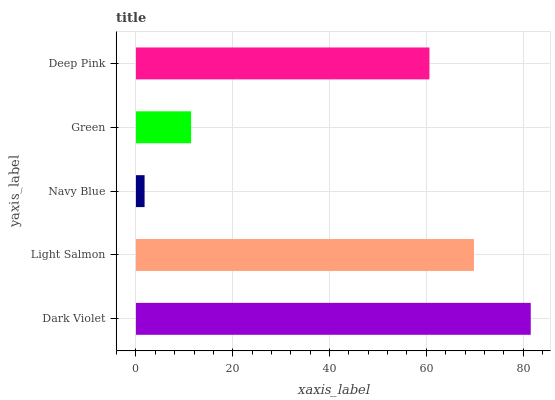Is Navy Blue the minimum?
Answer yes or no. Yes. Is Dark Violet the maximum?
Answer yes or no. Yes. Is Light Salmon the minimum?
Answer yes or no. No. Is Light Salmon the maximum?
Answer yes or no. No. Is Dark Violet greater than Light Salmon?
Answer yes or no. Yes. Is Light Salmon less than Dark Violet?
Answer yes or no. Yes. Is Light Salmon greater than Dark Violet?
Answer yes or no. No. Is Dark Violet less than Light Salmon?
Answer yes or no. No. Is Deep Pink the high median?
Answer yes or no. Yes. Is Deep Pink the low median?
Answer yes or no. Yes. Is Dark Violet the high median?
Answer yes or no. No. Is Navy Blue the low median?
Answer yes or no. No. 